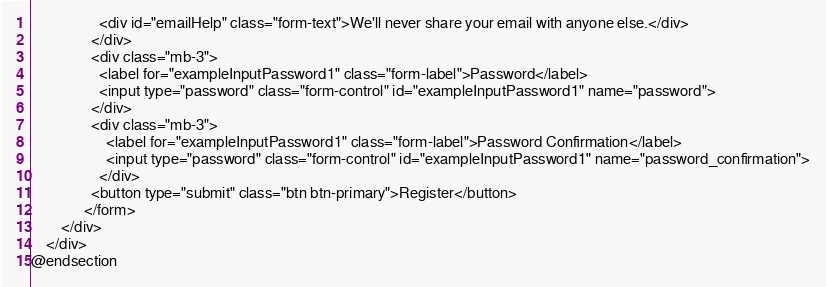Convert code to text. <code><loc_0><loc_0><loc_500><loc_500><_PHP_>                  <div id="emailHelp" class="form-text">We'll never share your email with anyone else.</div>
                </div>
                <div class="mb-3">
                  <label for="exampleInputPassword1" class="form-label">Password</label>
                  <input type="password" class="form-control" id="exampleInputPassword1" name="password">
                </div>
                <div class="mb-3">
                    <label for="exampleInputPassword1" class="form-label">Password Confirmation</label>
                    <input type="password" class="form-control" id="exampleInputPassword1" name="password_confirmation">
                  </div>
                <button type="submit" class="btn btn-primary">Register</button>
              </form>
        </div>
    </div>
@endsection</code> 